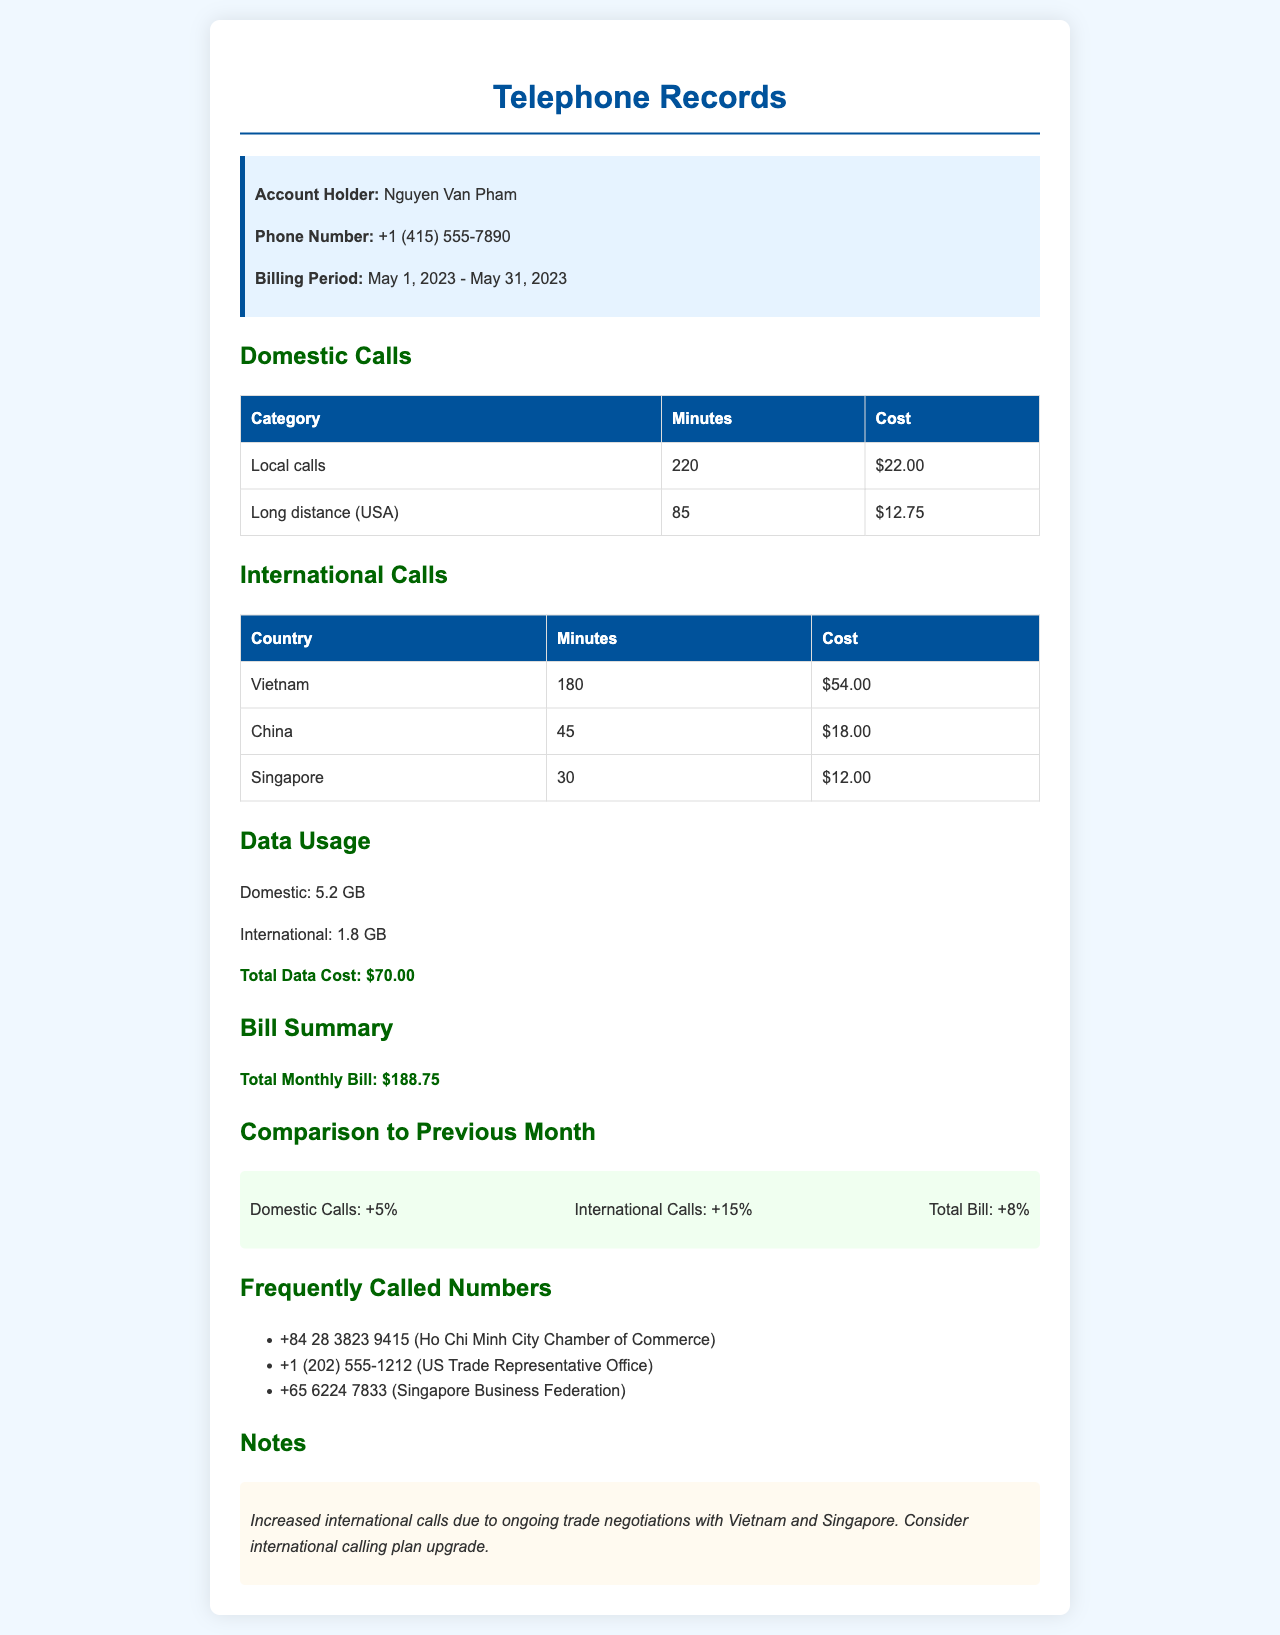What is the account holder's name? The document specifies the account holder as Nguyen Van Pham.
Answer: Nguyen Van Pham How many minutes were used for local calls? The document lists the minutes for local calls as 220.
Answer: 220 What is the total monthly bill? The total monthly bill is highlighted in the document as $188.75.
Answer: $188.75 What was the percentage increase in international calls compared to the previous month? The document states that international calls increased by 15%.
Answer: 15% How many minutes were spent on calls to Vietnam? The minutes for calls to Vietnam are shown as 180 in the international calls section.
Answer: 180 What is the total data usage for domestic calls? The document indicates the total data usage for domestic calls as 5.2 GB.
Answer: 5.2 GB What is the breakdown cost for long distance calls (USA)? The document shows that the cost of long distance calls (USA) is $12.75.
Answer: $12.75 Which office was frequently called from the US? The document notes the US Trade Representative Office as frequently called.
Answer: US Trade Representative Office What is the suggested consideration mentioned in the notes? The notes in the document suggest considering an international calling plan upgrade.
Answer: International calling plan upgrade 